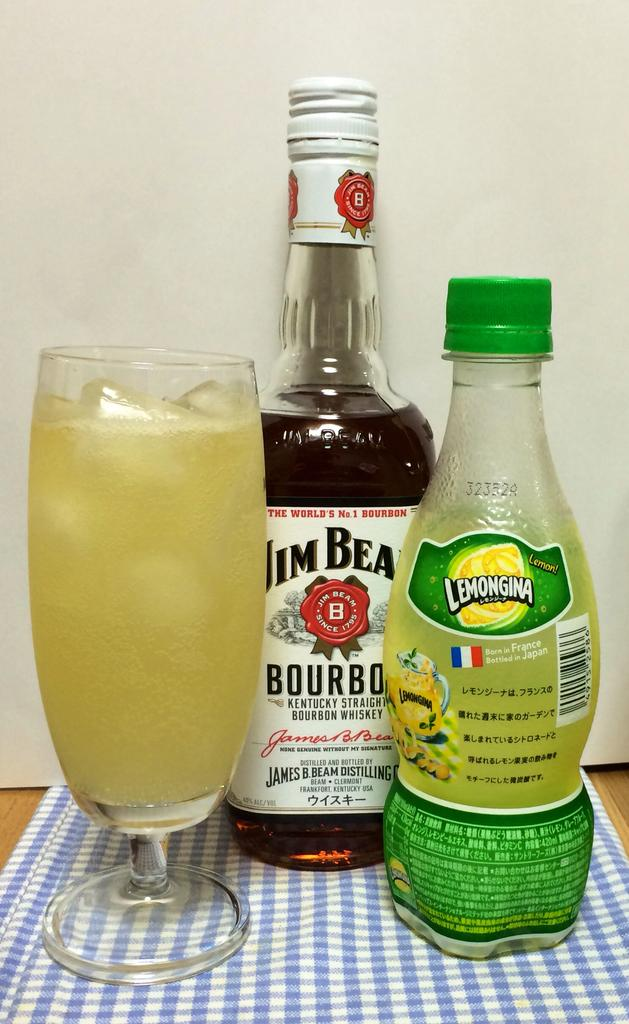<image>
Give a short and clear explanation of the subsequent image. A bottle of bourbon, a bottle of lemon juice, sit next to a glass filled to the top with ice and liquid. 